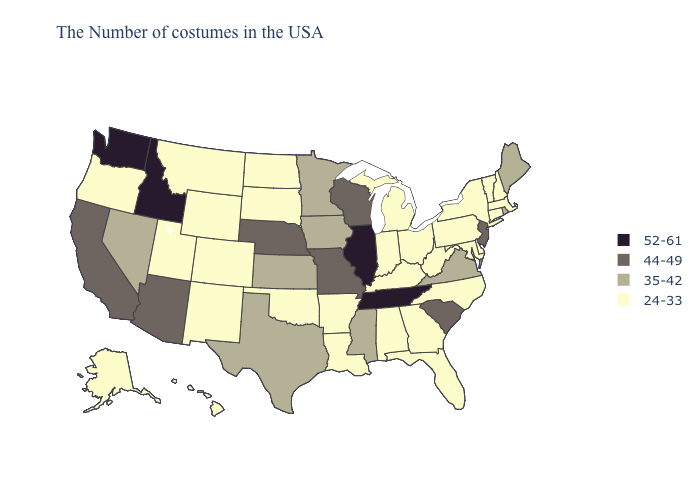Does South Carolina have the lowest value in the South?
Write a very short answer. No. What is the lowest value in the USA?
Concise answer only. 24-33. Does Virginia have the lowest value in the South?
Be succinct. No. How many symbols are there in the legend?
Quick response, please. 4. What is the lowest value in the USA?
Concise answer only. 24-33. What is the highest value in the USA?
Keep it brief. 52-61. Name the states that have a value in the range 35-42?
Give a very brief answer. Maine, Rhode Island, Virginia, Mississippi, Minnesota, Iowa, Kansas, Texas, Nevada. Which states hav the highest value in the South?
Be succinct. Tennessee. What is the lowest value in the USA?
Concise answer only. 24-33. Name the states that have a value in the range 35-42?
Concise answer only. Maine, Rhode Island, Virginia, Mississippi, Minnesota, Iowa, Kansas, Texas, Nevada. What is the value of Indiana?
Concise answer only. 24-33. Does Minnesota have the lowest value in the USA?
Keep it brief. No. Is the legend a continuous bar?
Write a very short answer. No. What is the lowest value in the USA?
Concise answer only. 24-33. Name the states that have a value in the range 35-42?
Keep it brief. Maine, Rhode Island, Virginia, Mississippi, Minnesota, Iowa, Kansas, Texas, Nevada. 